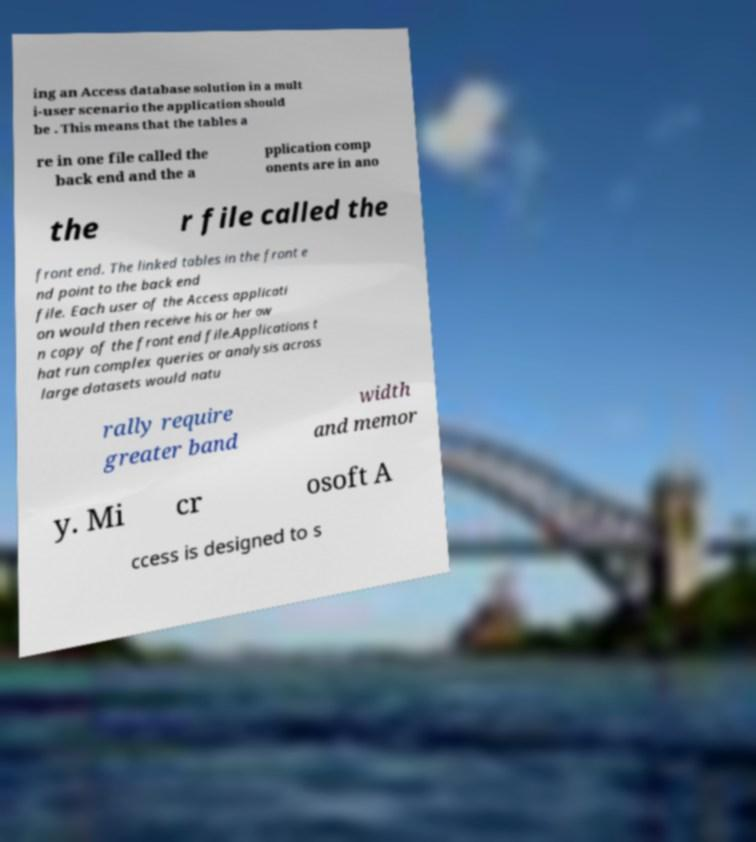Could you extract and type out the text from this image? ing an Access database solution in a mult i-user scenario the application should be . This means that the tables a re in one file called the back end and the a pplication comp onents are in ano the r file called the front end. The linked tables in the front e nd point to the back end file. Each user of the Access applicati on would then receive his or her ow n copy of the front end file.Applications t hat run complex queries or analysis across large datasets would natu rally require greater band width and memor y. Mi cr osoft A ccess is designed to s 